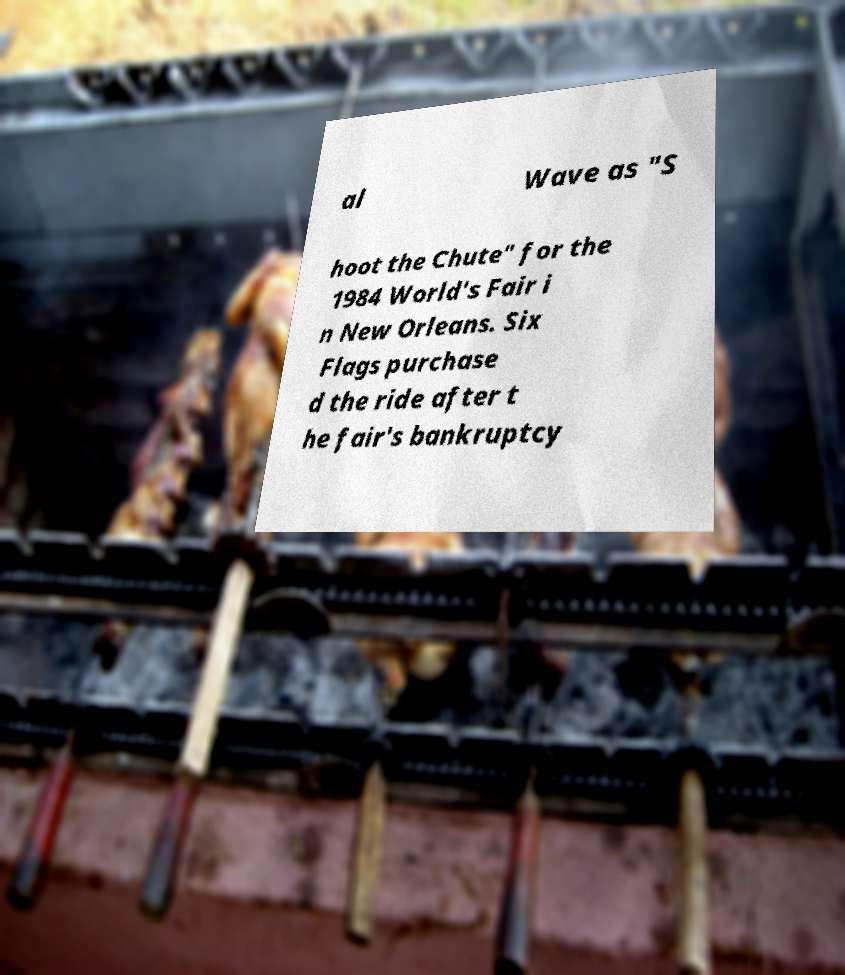Could you extract and type out the text from this image? al Wave as "S hoot the Chute" for the 1984 World's Fair i n New Orleans. Six Flags purchase d the ride after t he fair's bankruptcy 